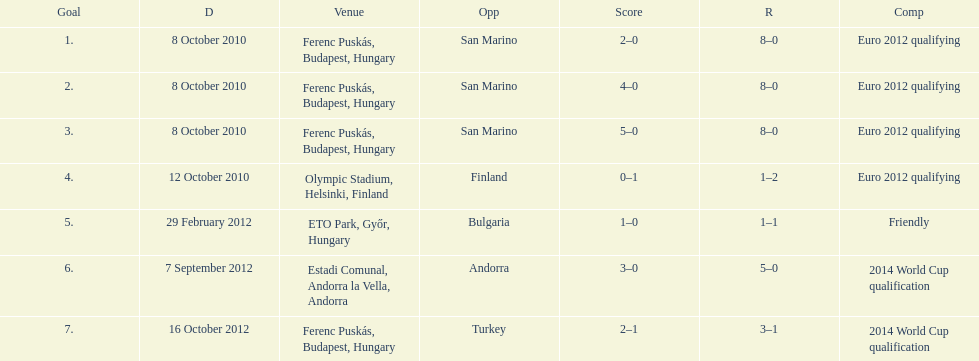Parse the full table. {'header': ['Goal', 'D', 'Venue', 'Opp', 'Score', 'R', 'Comp'], 'rows': [['1.', '8 October 2010', 'Ferenc Puskás, Budapest, Hungary', 'San Marino', '2–0', '8–0', 'Euro 2012 qualifying'], ['2.', '8 October 2010', 'Ferenc Puskás, Budapest, Hungary', 'San Marino', '4–0', '8–0', 'Euro 2012 qualifying'], ['3.', '8 October 2010', 'Ferenc Puskás, Budapest, Hungary', 'San Marino', '5–0', '8–0', 'Euro 2012 qualifying'], ['4.', '12 October 2010', 'Olympic Stadium, Helsinki, Finland', 'Finland', '0–1', '1–2', 'Euro 2012 qualifying'], ['5.', '29 February 2012', 'ETO Park, Győr, Hungary', 'Bulgaria', '1–0', '1–1', 'Friendly'], ['6.', '7 September 2012', 'Estadi Comunal, Andorra la Vella, Andorra', 'Andorra', '3–0', '5–0', '2014 World Cup qualification'], ['7.', '16 October 2012', 'Ferenc Puskás, Budapest, Hungary', 'Turkey', '2–1', '3–1', '2014 World Cup qualification']]} What is the total number of international goals ádám szalai has made? 7. 